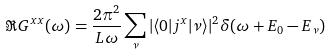Convert formula to latex. <formula><loc_0><loc_0><loc_500><loc_500>\Re G ^ { x x } ( \omega ) = \frac { 2 \pi ^ { 2 } } { L \omega } \sum _ { \nu } | \langle 0 | j ^ { x } | \nu \rangle | ^ { 2 } \delta ( \omega + E _ { 0 } - E _ { \nu } )</formula> 